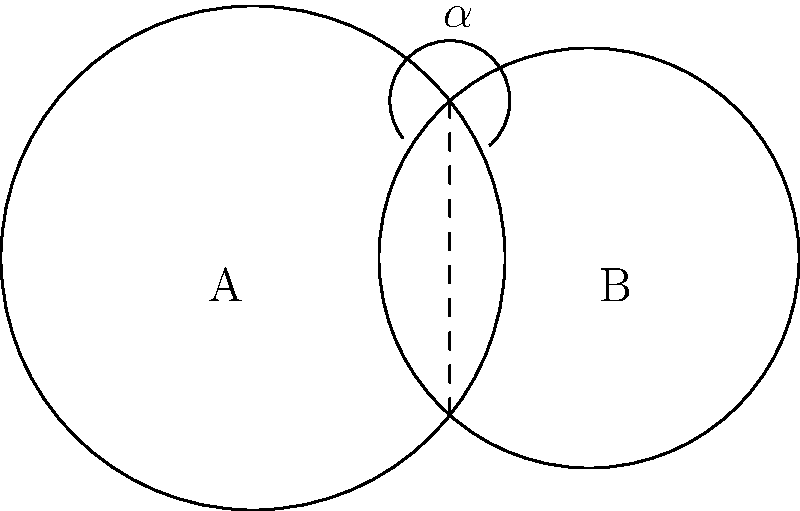In your many years of sharing experiences with friends and family, you've noticed how lives often intersect. Two circles represent the life experiences of you and a dear friend. Your circle, centered at A, has a radius of 3 units, while your friend's circle, centered at B, has a radius of 2.5 units. The centers are 4 units apart. If the overlapping region represents shared experiences, what is the area of this intersection? Round your answer to two decimal places. Let's approach this step-by-step:

1) First, we need to find the angle $\alpha$ in the diagram. We can do this using the cosine law:

   $\cos \alpha = \frac{r_1^2 + d^2 - r_2^2}{2r_1d}$

   Where $r_1 = 3$, $r_2 = 2.5$, and $d = 4$

2) Substituting these values:

   $\cos \alpha = \frac{3^2 + 4^2 - 2.5^2}{2 * 3 * 4} = 0.6979$

3) Taking arccos of both sides:

   $\alpha = \arccos(0.6979) = 0.8029$ radians

4) The area of intersection is given by:

   $A = r_1^2 \arccos(\frac{d^2 + r_1^2 - r_2^2}{2dr_1}) + r_2^2 \arccos(\frac{d^2 + r_2^2 - r_1^2}{2dr_2}) - \frac{1}{2}\sqrt{(-d+r_1+r_2)(d+r_1-r_2)(d-r_1+r_2)(d+r_1+r_2)}$

5) Substituting our values:

   $A = 3^2 * 0.8029 + 2.5^2 * 0.9097 - \frac{1}{2}\sqrt{(-4+3+2.5)(4+3-2.5)(4-3+2.5)(4+3+2.5)}$

6) Calculating:

   $A = 7.2261 + 5.6856 - 2.4408 = 10.4709$

7) Rounding to two decimal places:

   $A \approx 10.47$ square units
Answer: $10.47$ square units 